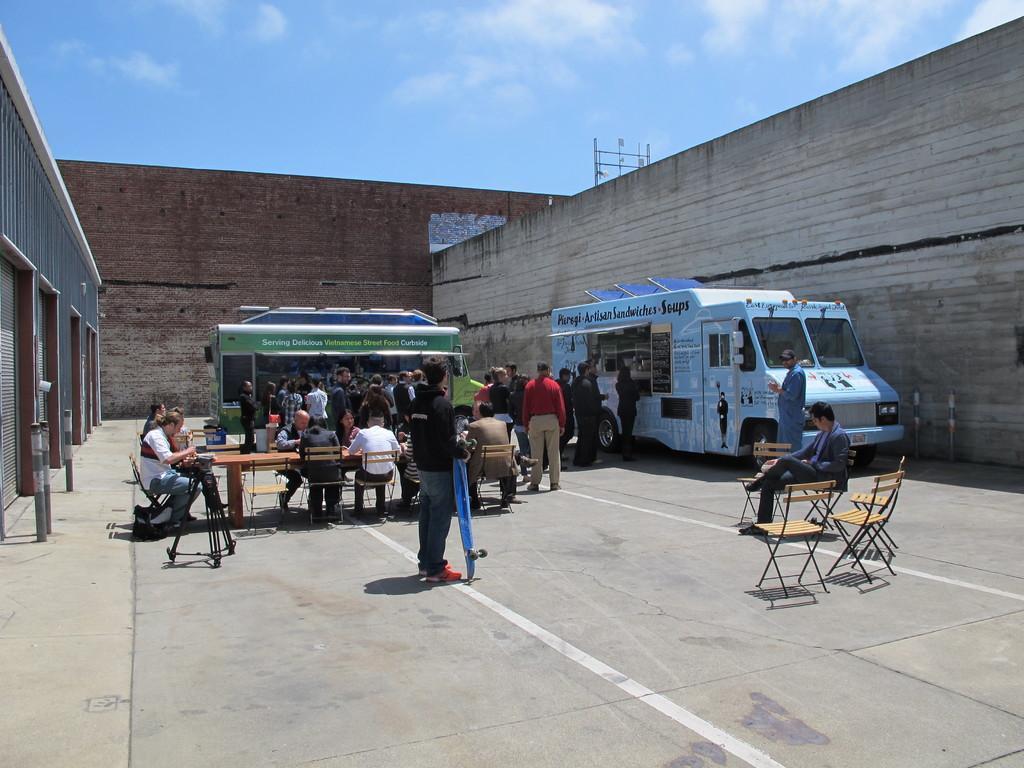Can you describe this image briefly? It consists of two food trucks. and there are many people are standing , few people are sitting. There are few chairs and table. The place is surrounded by buildings. On the top there is sky with cloud. 